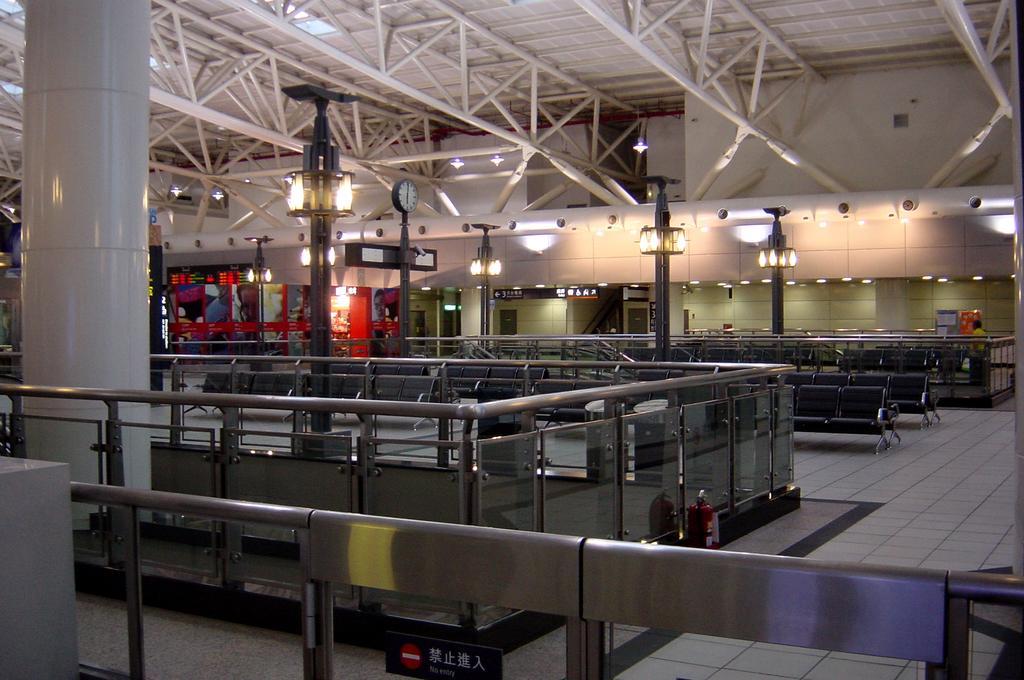Can you describe this image briefly? In this image there are light poles, clock pole and lights are present. Image also consists of black chairs and also glass fence. At the top there is roof for shelter and at the bottom there is floor. White pillar is also visible. 